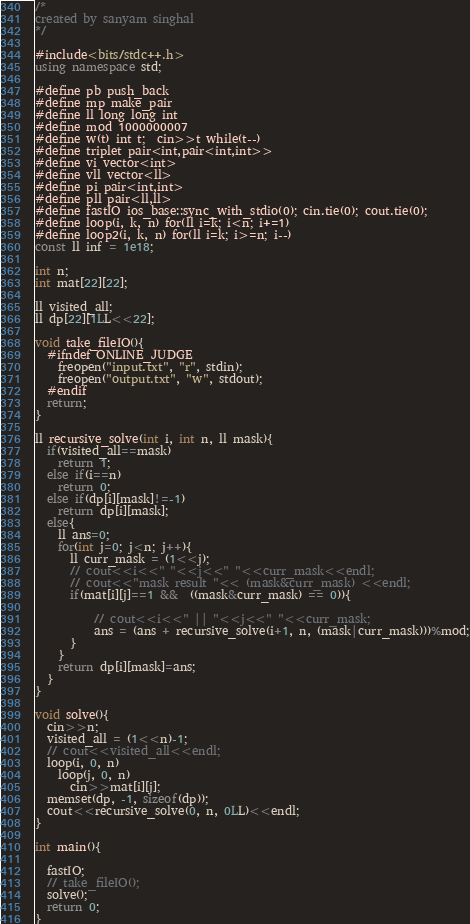<code> <loc_0><loc_0><loc_500><loc_500><_C++_>/*
created by sanyam singhal
*/

#include<bits/stdc++.h>
using namespace std;

#define pb push_back
#define mp make_pair
#define ll long long int
#define mod 1000000007
#define w(t) int t;	cin>>t while(t--)
#define triplet pair<int,pair<int,int>>
#define vi vector<int>
#define vll vector<ll>
#define pi pair<int,int>
#define pll pair<ll,ll>
#define fastIO ios_base::sync_with_stdio(0);	cin.tie(0);	cout.tie(0);
#define loop(i, k, n) for(ll i=k; i<n; i+=1)
#define loop2(i, k, n) for(ll i=k; i>=n; i--)
const ll inf = 1e18;

int n;  
int mat[22][22];

ll visited_all;
ll dp[22][1LL<<22];

void take_fileIO(){
  #ifndef ONLINE_JUDGE
    freopen("input.txt", "r", stdin);
    freopen("output.txt", "w", stdout);
  #endif
  return;
}

ll recursive_solve(int i, int n, ll mask){
  if(visited_all==mask)
    return 1;
  else if(i==n)
    return 0;
  else if(dp[i][mask]!=-1)
    return dp[i][mask];
  else{
    ll ans=0;
    for(int j=0; j<n; j++){
      ll curr_mask = (1<<j);
      // cout<<i<<" "<<j<<" "<<curr_mask<<endl;
      // cout<<"mask result "<< (mask&curr_mask) <<endl;
      if(mat[i][j]==1 &&  ((mask&curr_mask) == 0)){

          // cout<<i<<" || "<<j<<" "<<curr_mask;
          ans = (ans + recursive_solve(i+1, n, (mask|curr_mask)))%mod;
      }
    }
    return dp[i][mask]=ans;
  }
}

void solve(){ 
  cin>>n;
  visited_all = (1<<n)-1;
  // cout<<visited_all<<endl;
  loop(i, 0, n)
    loop(j, 0, n)
      cin>>mat[i][j];
  memset(dp, -1, sizeof(dp));
  cout<<recursive_solve(0, n, 0LL)<<endl;
}

int main(){

  fastIO;
  // take_fileIO();
  solve();
  return 0;
}</code> 